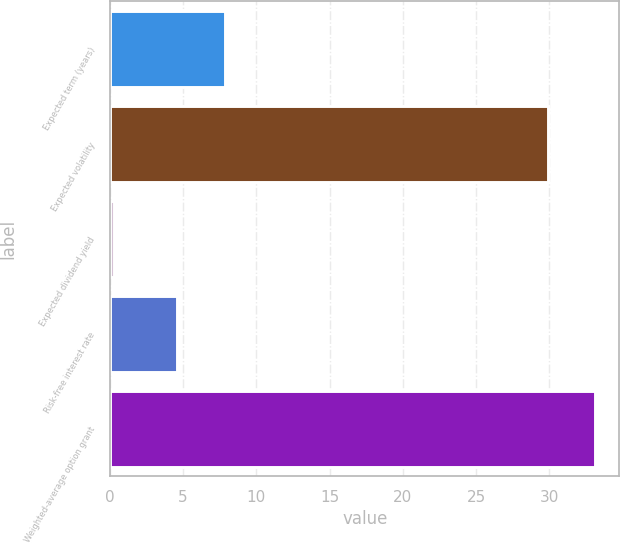<chart> <loc_0><loc_0><loc_500><loc_500><bar_chart><fcel>Expected term (years)<fcel>Expected volatility<fcel>Expected dividend yield<fcel>Risk-free interest rate<fcel>Weighted-average option grant<nl><fcel>7.84<fcel>29.9<fcel>0.26<fcel>4.6<fcel>33.14<nl></chart> 